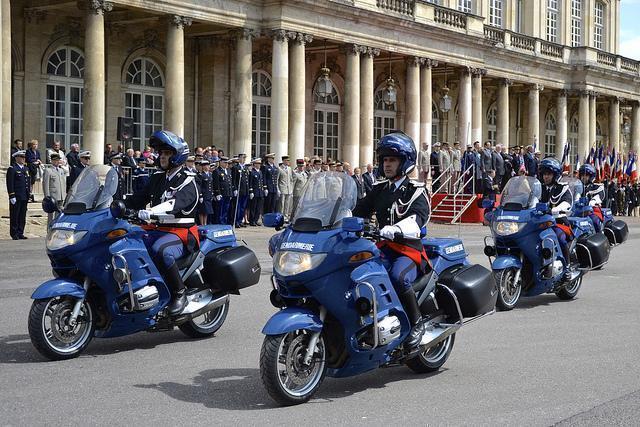What type of outfit are the men on the motorcycles wearing?
From the following four choices, select the correct answer to address the question.
Options: Beach wear, uniform, casual, sweatsuits. Uniform. 